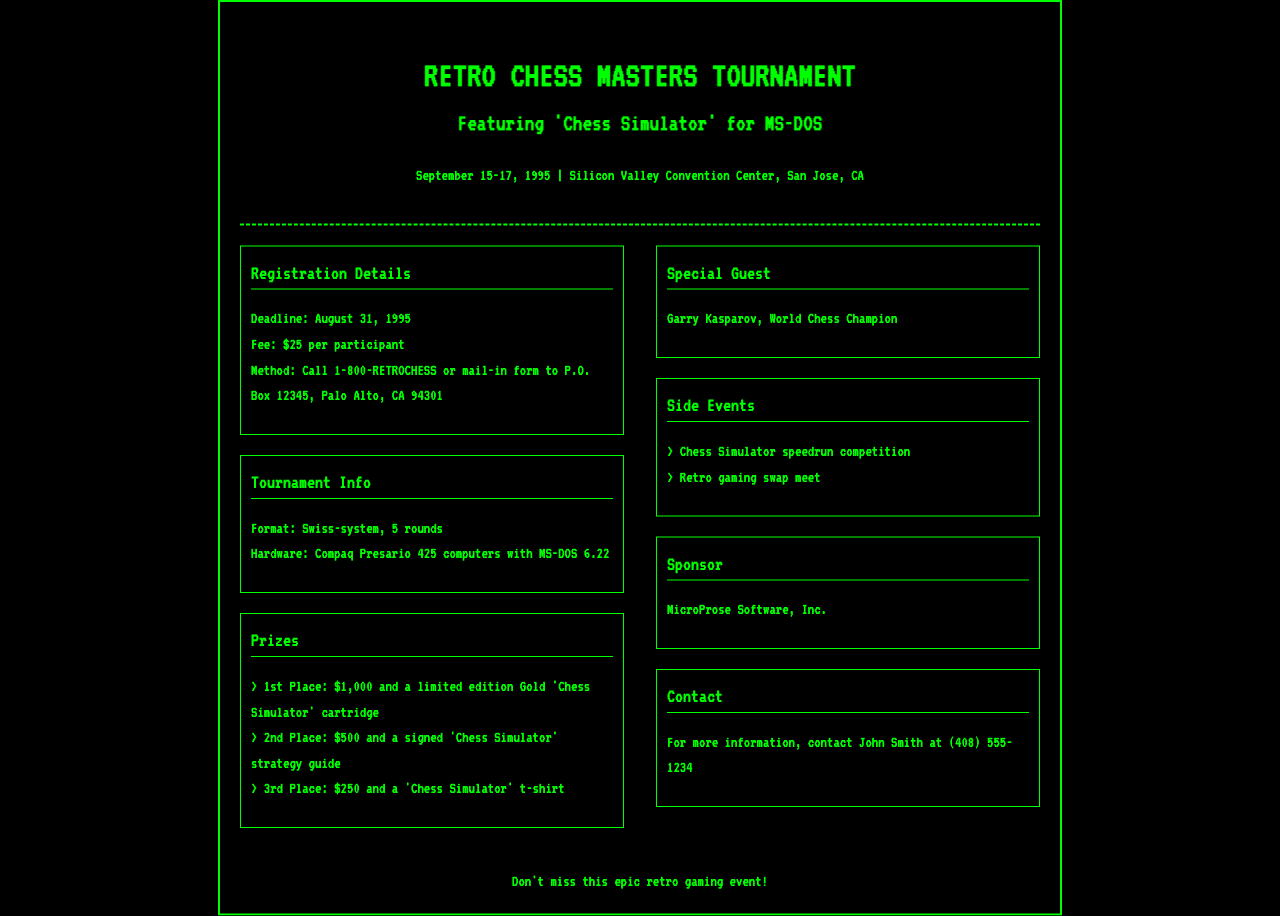What are the tournament dates? The tournament takes place from September 15 to 17, 1995, as stated in the document.
Answer: September 15-17, 1995 What is the registration deadline? The registration deadline is mentioned clearly in the registration details section.
Answer: August 31, 1995 How much is the registration fee? The document specifies the fee amount in the registration details section.
Answer: $25 Who is the special guest for the tournament? The special guest is identified in the document under the special guest section.
Answer: Garry Kasparov What is the prize for 1st place? The prize for 1st place is outlined in the prizes section of the document.
Answer: $1,000 and a limited edition Gold 'Chess Simulator' cartridge What format will the tournament follow? The tournament format is specified in the tournament info section.
Answer: Swiss-system, 5 rounds What is the contact number for more information? The contact number is provided in the contact section of the document.
Answer: (408) 555-1234 What type of computers will be used in the tournament? The document mentions the type of hardware in the tournament info section.
Answer: Compaq Presario 425 computers with MS-DOS 6.22 What company is sponsoring the tournament? The sponsor is listed in the document under the sponsor section.
Answer: MicroProse Software, Inc 